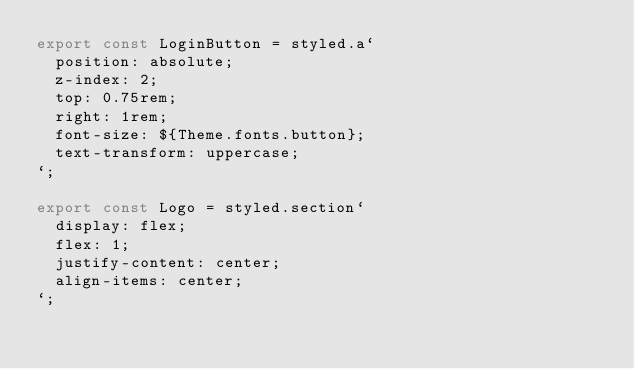Convert code to text. <code><loc_0><loc_0><loc_500><loc_500><_TypeScript_>export const LoginButton = styled.a`
  position: absolute;
  z-index: 2;
  top: 0.75rem;
  right: 1rem;
  font-size: ${Theme.fonts.button};
  text-transform: uppercase;
`;

export const Logo = styled.section`
  display: flex;
  flex: 1;
  justify-content: center;
  align-items: center;
`;</code> 